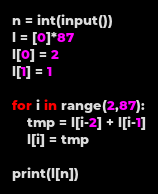<code> <loc_0><loc_0><loc_500><loc_500><_Python_>n = int(input())
l = [0]*87
l[0] = 2
l[1] = 1

for i in range(2,87):
    tmp = l[i-2] + l[i-1]
    l[i] = tmp

print(l[n])</code> 